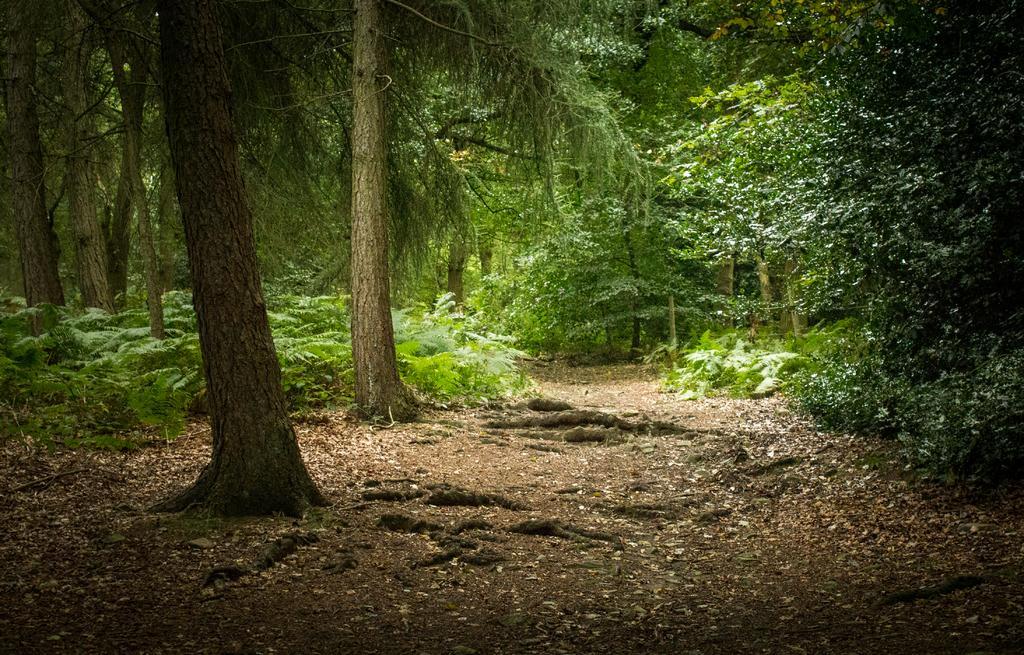Describe this image in one or two sentences. In this image, we can see some green plants and trees. 